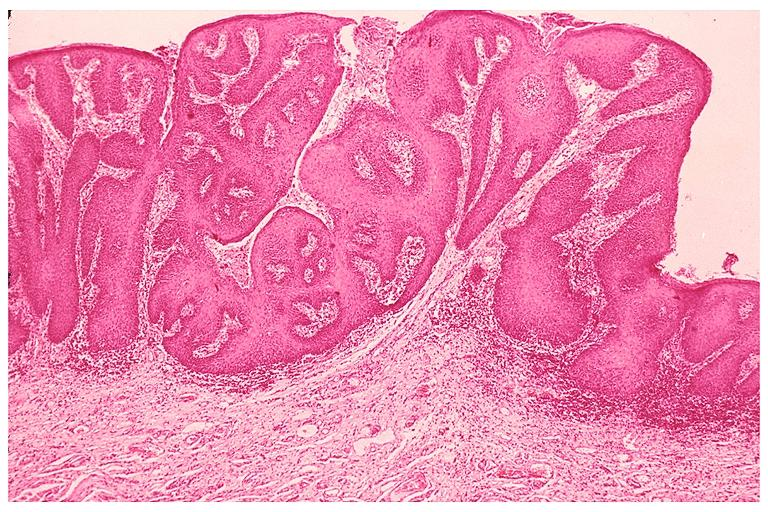s oral present?
Answer the question using a single word or phrase. Yes 